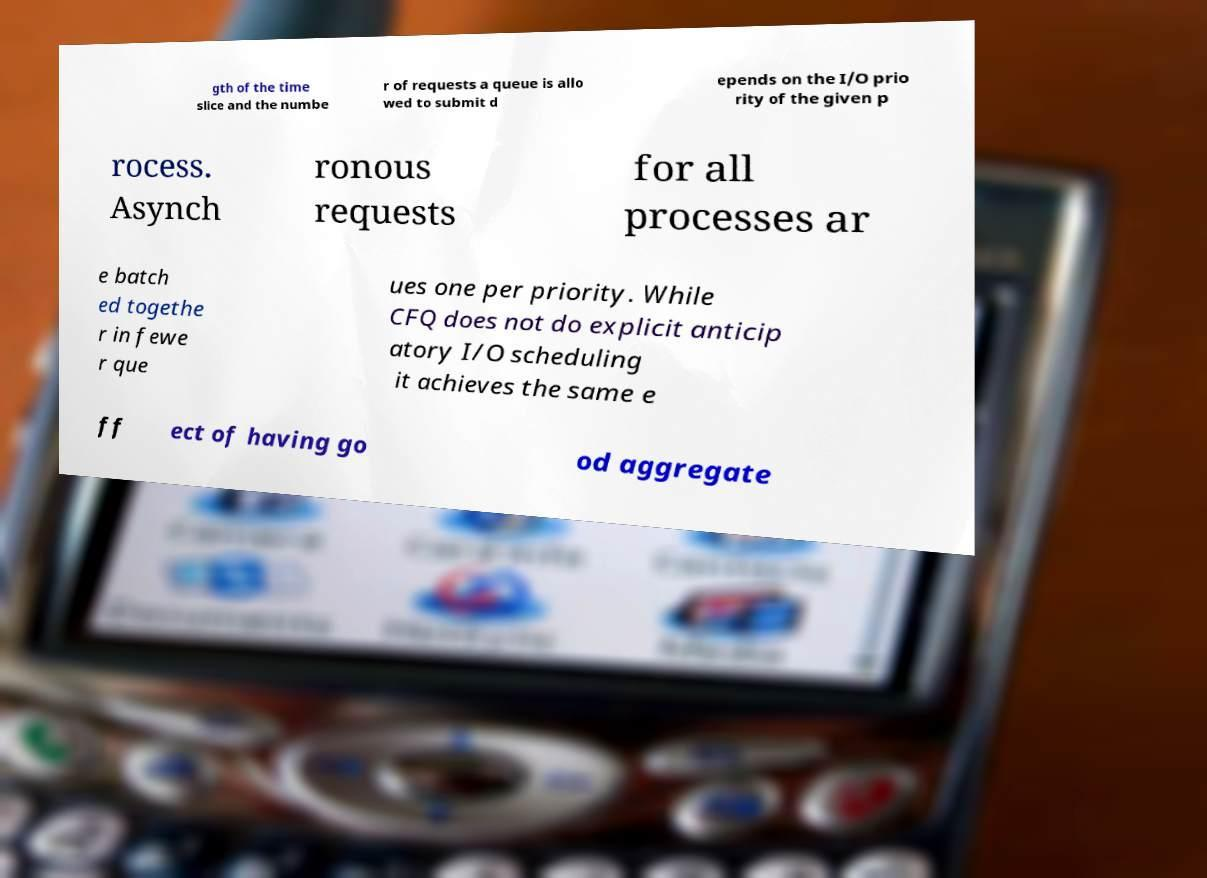Can you accurately transcribe the text from the provided image for me? gth of the time slice and the numbe r of requests a queue is allo wed to submit d epends on the I/O prio rity of the given p rocess. Asynch ronous requests for all processes ar e batch ed togethe r in fewe r que ues one per priority. While CFQ does not do explicit anticip atory I/O scheduling it achieves the same e ff ect of having go od aggregate 